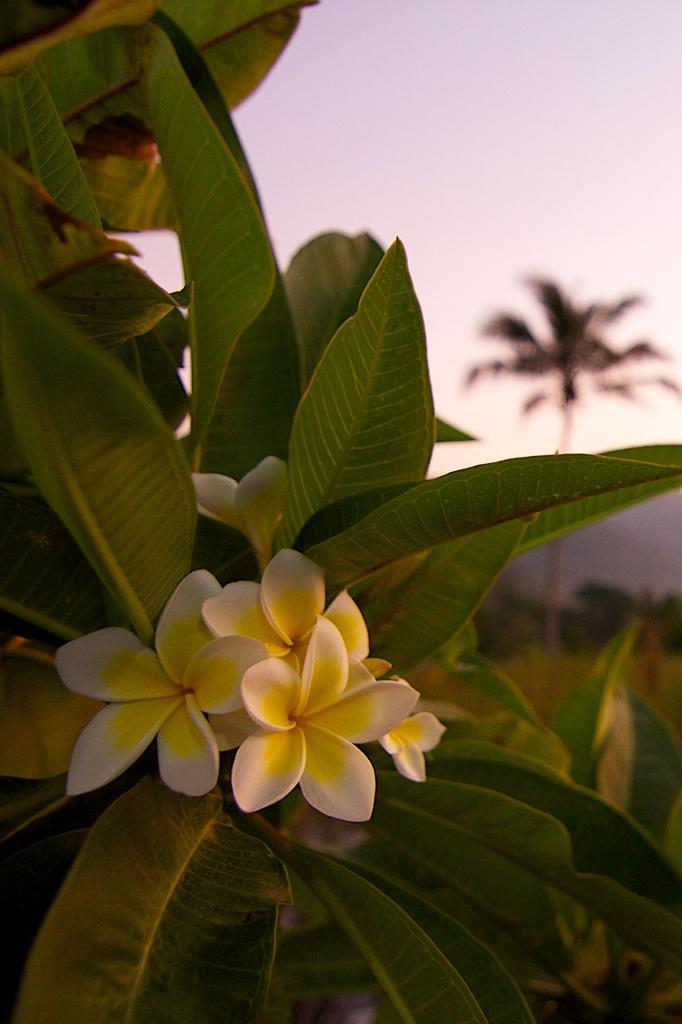What type of plant life is visible in the image? There are flowers and leaves in the image. What can be seen in the background of the image? There are trees in the background of the image. How is the background of the image depicted? The background is blurred. What type of hair can be seen on the flowers in the image? There is no hair present on the flowers in the image. 